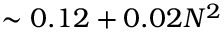Convert formula to latex. <formula><loc_0><loc_0><loc_500><loc_500>\sim 0 . 1 2 + 0 . 0 2 N ^ { 2 }</formula> 